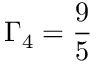<formula> <loc_0><loc_0><loc_500><loc_500>\Gamma _ { 4 } = \frac { 9 } { 5 }</formula> 